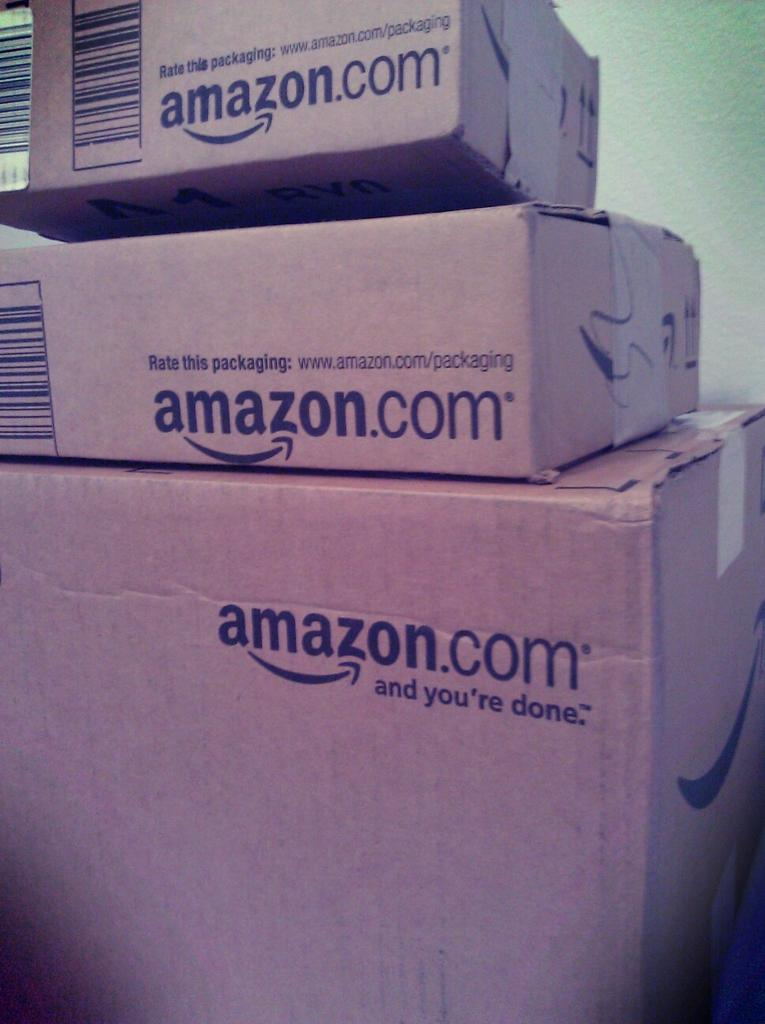<image>
Give a short and clear explanation of the subsequent image. Boxes, labelled as being from amazon.com, are stacked up. 